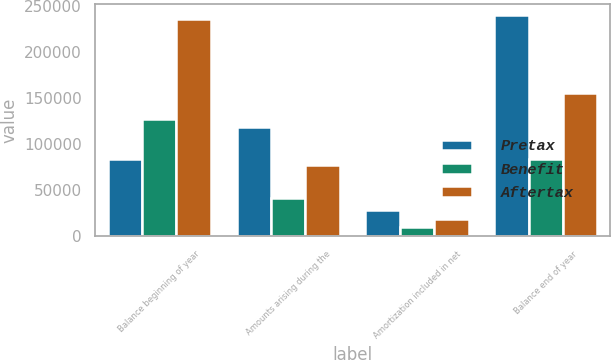Convert chart to OTSL. <chart><loc_0><loc_0><loc_500><loc_500><stacked_bar_chart><ecel><fcel>Balance beginning of year<fcel>Amounts arising during the<fcel>Amortization included in net<fcel>Balance end of year<nl><fcel>Pretax<fcel>84122<fcel>118666<fcel>29194<fcel>240345<nl><fcel>Benefit<fcel>127292<fcel>41532<fcel>10218<fcel>84122<nl><fcel>Aftertax<fcel>236399<fcel>77134<fcel>18976<fcel>156223<nl></chart> 